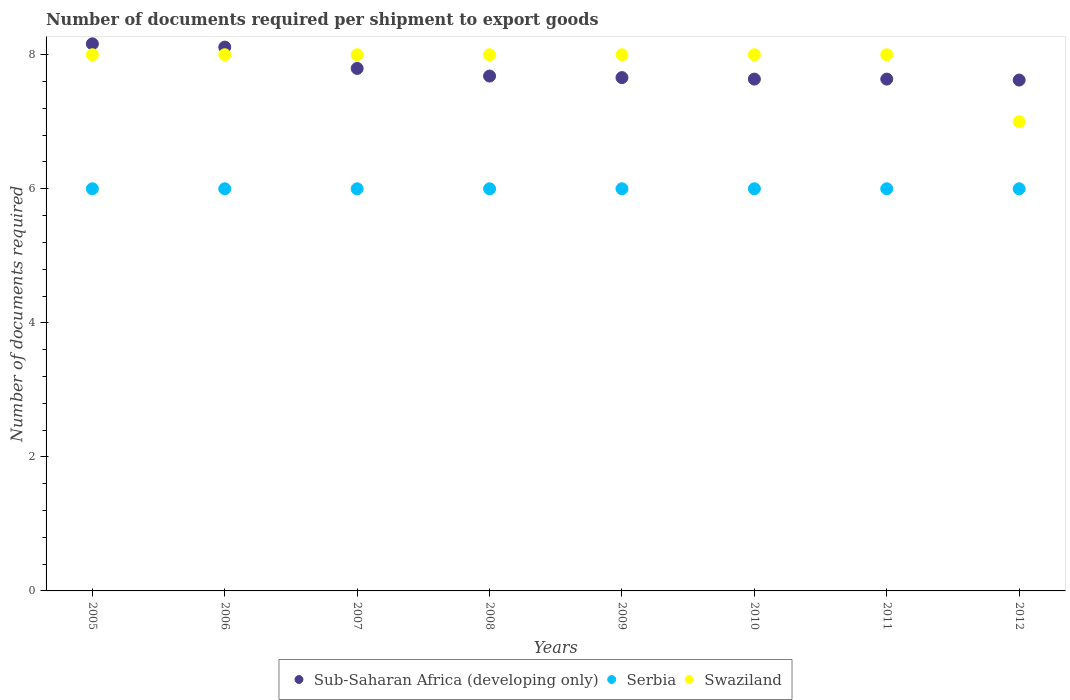How many different coloured dotlines are there?
Your answer should be compact. 3. Is the number of dotlines equal to the number of legend labels?
Your answer should be very brief. Yes. What is the number of documents required per shipment to export goods in Serbia in 2005?
Keep it short and to the point. 6. Across all years, what is the maximum number of documents required per shipment to export goods in Sub-Saharan Africa (developing only)?
Make the answer very short. 8.16. Across all years, what is the minimum number of documents required per shipment to export goods in Swaziland?
Provide a succinct answer. 7. What is the total number of documents required per shipment to export goods in Sub-Saharan Africa (developing only) in the graph?
Give a very brief answer. 62.31. What is the difference between the number of documents required per shipment to export goods in Sub-Saharan Africa (developing only) in 2005 and the number of documents required per shipment to export goods in Swaziland in 2008?
Your answer should be compact. 0.16. What is the average number of documents required per shipment to export goods in Serbia per year?
Ensure brevity in your answer.  6. In the year 2011, what is the difference between the number of documents required per shipment to export goods in Swaziland and number of documents required per shipment to export goods in Sub-Saharan Africa (developing only)?
Ensure brevity in your answer.  0.36. In how many years, is the number of documents required per shipment to export goods in Swaziland greater than 6.4?
Keep it short and to the point. 8. What is the ratio of the number of documents required per shipment to export goods in Sub-Saharan Africa (developing only) in 2007 to that in 2009?
Provide a short and direct response. 1.02. Is the number of documents required per shipment to export goods in Sub-Saharan Africa (developing only) in 2007 less than that in 2011?
Offer a very short reply. No. Is the difference between the number of documents required per shipment to export goods in Swaziland in 2009 and 2012 greater than the difference between the number of documents required per shipment to export goods in Sub-Saharan Africa (developing only) in 2009 and 2012?
Ensure brevity in your answer.  Yes. What is the difference between the highest and the second highest number of documents required per shipment to export goods in Serbia?
Your response must be concise. 0. What is the difference between the highest and the lowest number of documents required per shipment to export goods in Swaziland?
Provide a short and direct response. 1. Is it the case that in every year, the sum of the number of documents required per shipment to export goods in Sub-Saharan Africa (developing only) and number of documents required per shipment to export goods in Serbia  is greater than the number of documents required per shipment to export goods in Swaziland?
Your answer should be very brief. Yes. Does the number of documents required per shipment to export goods in Serbia monotonically increase over the years?
Your answer should be very brief. No. Is the number of documents required per shipment to export goods in Swaziland strictly greater than the number of documents required per shipment to export goods in Sub-Saharan Africa (developing only) over the years?
Your response must be concise. No. Is the number of documents required per shipment to export goods in Sub-Saharan Africa (developing only) strictly less than the number of documents required per shipment to export goods in Swaziland over the years?
Your answer should be compact. No. How many years are there in the graph?
Provide a succinct answer. 8. How many legend labels are there?
Ensure brevity in your answer.  3. What is the title of the graph?
Keep it short and to the point. Number of documents required per shipment to export goods. What is the label or title of the X-axis?
Keep it short and to the point. Years. What is the label or title of the Y-axis?
Ensure brevity in your answer.  Number of documents required. What is the Number of documents required in Sub-Saharan Africa (developing only) in 2005?
Offer a very short reply. 8.16. What is the Number of documents required of Swaziland in 2005?
Ensure brevity in your answer.  8. What is the Number of documents required of Sub-Saharan Africa (developing only) in 2006?
Provide a succinct answer. 8.11. What is the Number of documents required of Swaziland in 2006?
Your answer should be compact. 8. What is the Number of documents required of Sub-Saharan Africa (developing only) in 2007?
Offer a very short reply. 7.8. What is the Number of documents required in Swaziland in 2007?
Provide a succinct answer. 8. What is the Number of documents required in Sub-Saharan Africa (developing only) in 2008?
Your answer should be compact. 7.68. What is the Number of documents required of Serbia in 2008?
Make the answer very short. 6. What is the Number of documents required in Swaziland in 2008?
Offer a terse response. 8. What is the Number of documents required of Sub-Saharan Africa (developing only) in 2009?
Give a very brief answer. 7.66. What is the Number of documents required of Swaziland in 2009?
Provide a short and direct response. 8. What is the Number of documents required in Sub-Saharan Africa (developing only) in 2010?
Give a very brief answer. 7.64. What is the Number of documents required of Serbia in 2010?
Give a very brief answer. 6. What is the Number of documents required of Swaziland in 2010?
Offer a terse response. 8. What is the Number of documents required in Sub-Saharan Africa (developing only) in 2011?
Offer a very short reply. 7.64. What is the Number of documents required in Serbia in 2011?
Your answer should be very brief. 6. What is the Number of documents required in Sub-Saharan Africa (developing only) in 2012?
Offer a terse response. 7.62. Across all years, what is the maximum Number of documents required of Sub-Saharan Africa (developing only)?
Your response must be concise. 8.16. Across all years, what is the maximum Number of documents required of Swaziland?
Provide a succinct answer. 8. Across all years, what is the minimum Number of documents required of Sub-Saharan Africa (developing only)?
Make the answer very short. 7.62. What is the total Number of documents required in Sub-Saharan Africa (developing only) in the graph?
Make the answer very short. 62.31. What is the total Number of documents required of Swaziland in the graph?
Ensure brevity in your answer.  63. What is the difference between the Number of documents required of Sub-Saharan Africa (developing only) in 2005 and that in 2006?
Keep it short and to the point. 0.05. What is the difference between the Number of documents required of Sub-Saharan Africa (developing only) in 2005 and that in 2007?
Offer a terse response. 0.37. What is the difference between the Number of documents required of Sub-Saharan Africa (developing only) in 2005 and that in 2008?
Make the answer very short. 0.48. What is the difference between the Number of documents required of Serbia in 2005 and that in 2008?
Make the answer very short. 0. What is the difference between the Number of documents required in Sub-Saharan Africa (developing only) in 2005 and that in 2009?
Offer a terse response. 0.5. What is the difference between the Number of documents required of Serbia in 2005 and that in 2009?
Give a very brief answer. 0. What is the difference between the Number of documents required of Sub-Saharan Africa (developing only) in 2005 and that in 2010?
Make the answer very short. 0.53. What is the difference between the Number of documents required of Swaziland in 2005 and that in 2010?
Ensure brevity in your answer.  0. What is the difference between the Number of documents required in Sub-Saharan Africa (developing only) in 2005 and that in 2011?
Your answer should be compact. 0.53. What is the difference between the Number of documents required of Serbia in 2005 and that in 2011?
Offer a terse response. 0. What is the difference between the Number of documents required of Sub-Saharan Africa (developing only) in 2005 and that in 2012?
Give a very brief answer. 0.54. What is the difference between the Number of documents required of Serbia in 2005 and that in 2012?
Ensure brevity in your answer.  0. What is the difference between the Number of documents required in Swaziland in 2005 and that in 2012?
Keep it short and to the point. 1. What is the difference between the Number of documents required in Sub-Saharan Africa (developing only) in 2006 and that in 2007?
Offer a very short reply. 0.32. What is the difference between the Number of documents required of Serbia in 2006 and that in 2007?
Your answer should be compact. 0. What is the difference between the Number of documents required in Swaziland in 2006 and that in 2007?
Keep it short and to the point. 0. What is the difference between the Number of documents required in Sub-Saharan Africa (developing only) in 2006 and that in 2008?
Give a very brief answer. 0.43. What is the difference between the Number of documents required in Swaziland in 2006 and that in 2008?
Offer a very short reply. 0. What is the difference between the Number of documents required in Sub-Saharan Africa (developing only) in 2006 and that in 2009?
Provide a succinct answer. 0.45. What is the difference between the Number of documents required in Sub-Saharan Africa (developing only) in 2006 and that in 2010?
Ensure brevity in your answer.  0.48. What is the difference between the Number of documents required in Swaziland in 2006 and that in 2010?
Provide a short and direct response. 0. What is the difference between the Number of documents required of Sub-Saharan Africa (developing only) in 2006 and that in 2011?
Your answer should be compact. 0.48. What is the difference between the Number of documents required in Swaziland in 2006 and that in 2011?
Provide a short and direct response. 0. What is the difference between the Number of documents required in Sub-Saharan Africa (developing only) in 2006 and that in 2012?
Provide a succinct answer. 0.49. What is the difference between the Number of documents required in Serbia in 2006 and that in 2012?
Give a very brief answer. 0. What is the difference between the Number of documents required in Sub-Saharan Africa (developing only) in 2007 and that in 2008?
Your answer should be compact. 0.11. What is the difference between the Number of documents required of Serbia in 2007 and that in 2008?
Make the answer very short. 0. What is the difference between the Number of documents required in Sub-Saharan Africa (developing only) in 2007 and that in 2009?
Ensure brevity in your answer.  0.14. What is the difference between the Number of documents required of Sub-Saharan Africa (developing only) in 2007 and that in 2010?
Give a very brief answer. 0.16. What is the difference between the Number of documents required in Swaziland in 2007 and that in 2010?
Make the answer very short. 0. What is the difference between the Number of documents required in Sub-Saharan Africa (developing only) in 2007 and that in 2011?
Give a very brief answer. 0.16. What is the difference between the Number of documents required in Swaziland in 2007 and that in 2011?
Give a very brief answer. 0. What is the difference between the Number of documents required of Sub-Saharan Africa (developing only) in 2007 and that in 2012?
Provide a succinct answer. 0.17. What is the difference between the Number of documents required in Serbia in 2007 and that in 2012?
Offer a very short reply. 0. What is the difference between the Number of documents required in Sub-Saharan Africa (developing only) in 2008 and that in 2009?
Give a very brief answer. 0.02. What is the difference between the Number of documents required of Serbia in 2008 and that in 2009?
Ensure brevity in your answer.  0. What is the difference between the Number of documents required of Swaziland in 2008 and that in 2009?
Provide a short and direct response. 0. What is the difference between the Number of documents required in Sub-Saharan Africa (developing only) in 2008 and that in 2010?
Provide a succinct answer. 0.05. What is the difference between the Number of documents required of Sub-Saharan Africa (developing only) in 2008 and that in 2011?
Provide a succinct answer. 0.05. What is the difference between the Number of documents required in Serbia in 2008 and that in 2011?
Provide a succinct answer. 0. What is the difference between the Number of documents required in Swaziland in 2008 and that in 2011?
Your answer should be very brief. 0. What is the difference between the Number of documents required of Sub-Saharan Africa (developing only) in 2008 and that in 2012?
Offer a very short reply. 0.06. What is the difference between the Number of documents required of Sub-Saharan Africa (developing only) in 2009 and that in 2010?
Provide a succinct answer. 0.02. What is the difference between the Number of documents required of Sub-Saharan Africa (developing only) in 2009 and that in 2011?
Ensure brevity in your answer.  0.02. What is the difference between the Number of documents required in Sub-Saharan Africa (developing only) in 2009 and that in 2012?
Ensure brevity in your answer.  0.04. What is the difference between the Number of documents required in Serbia in 2009 and that in 2012?
Provide a succinct answer. 0. What is the difference between the Number of documents required in Swaziland in 2009 and that in 2012?
Your answer should be very brief. 1. What is the difference between the Number of documents required of Sub-Saharan Africa (developing only) in 2010 and that in 2011?
Provide a short and direct response. 0. What is the difference between the Number of documents required in Serbia in 2010 and that in 2011?
Keep it short and to the point. 0. What is the difference between the Number of documents required of Sub-Saharan Africa (developing only) in 2010 and that in 2012?
Offer a terse response. 0.01. What is the difference between the Number of documents required of Swaziland in 2010 and that in 2012?
Offer a very short reply. 1. What is the difference between the Number of documents required in Sub-Saharan Africa (developing only) in 2011 and that in 2012?
Provide a succinct answer. 0.01. What is the difference between the Number of documents required of Serbia in 2011 and that in 2012?
Make the answer very short. 0. What is the difference between the Number of documents required of Swaziland in 2011 and that in 2012?
Your answer should be compact. 1. What is the difference between the Number of documents required of Sub-Saharan Africa (developing only) in 2005 and the Number of documents required of Serbia in 2006?
Provide a succinct answer. 2.16. What is the difference between the Number of documents required in Sub-Saharan Africa (developing only) in 2005 and the Number of documents required in Swaziland in 2006?
Provide a succinct answer. 0.16. What is the difference between the Number of documents required of Sub-Saharan Africa (developing only) in 2005 and the Number of documents required of Serbia in 2007?
Provide a succinct answer. 2.16. What is the difference between the Number of documents required in Sub-Saharan Africa (developing only) in 2005 and the Number of documents required in Swaziland in 2007?
Your response must be concise. 0.16. What is the difference between the Number of documents required of Sub-Saharan Africa (developing only) in 2005 and the Number of documents required of Serbia in 2008?
Provide a short and direct response. 2.16. What is the difference between the Number of documents required of Sub-Saharan Africa (developing only) in 2005 and the Number of documents required of Swaziland in 2008?
Provide a succinct answer. 0.16. What is the difference between the Number of documents required in Serbia in 2005 and the Number of documents required in Swaziland in 2008?
Give a very brief answer. -2. What is the difference between the Number of documents required in Sub-Saharan Africa (developing only) in 2005 and the Number of documents required in Serbia in 2009?
Provide a short and direct response. 2.16. What is the difference between the Number of documents required of Sub-Saharan Africa (developing only) in 2005 and the Number of documents required of Swaziland in 2009?
Provide a succinct answer. 0.16. What is the difference between the Number of documents required of Sub-Saharan Africa (developing only) in 2005 and the Number of documents required of Serbia in 2010?
Your response must be concise. 2.16. What is the difference between the Number of documents required in Sub-Saharan Africa (developing only) in 2005 and the Number of documents required in Swaziland in 2010?
Offer a terse response. 0.16. What is the difference between the Number of documents required of Sub-Saharan Africa (developing only) in 2005 and the Number of documents required of Serbia in 2011?
Give a very brief answer. 2.16. What is the difference between the Number of documents required in Sub-Saharan Africa (developing only) in 2005 and the Number of documents required in Swaziland in 2011?
Keep it short and to the point. 0.16. What is the difference between the Number of documents required of Sub-Saharan Africa (developing only) in 2005 and the Number of documents required of Serbia in 2012?
Give a very brief answer. 2.16. What is the difference between the Number of documents required in Sub-Saharan Africa (developing only) in 2005 and the Number of documents required in Swaziland in 2012?
Ensure brevity in your answer.  1.16. What is the difference between the Number of documents required of Serbia in 2005 and the Number of documents required of Swaziland in 2012?
Your answer should be compact. -1. What is the difference between the Number of documents required in Sub-Saharan Africa (developing only) in 2006 and the Number of documents required in Serbia in 2007?
Your response must be concise. 2.11. What is the difference between the Number of documents required of Sub-Saharan Africa (developing only) in 2006 and the Number of documents required of Swaziland in 2007?
Provide a succinct answer. 0.11. What is the difference between the Number of documents required of Sub-Saharan Africa (developing only) in 2006 and the Number of documents required of Serbia in 2008?
Provide a succinct answer. 2.11. What is the difference between the Number of documents required of Sub-Saharan Africa (developing only) in 2006 and the Number of documents required of Swaziland in 2008?
Your answer should be compact. 0.11. What is the difference between the Number of documents required of Serbia in 2006 and the Number of documents required of Swaziland in 2008?
Keep it short and to the point. -2. What is the difference between the Number of documents required in Sub-Saharan Africa (developing only) in 2006 and the Number of documents required in Serbia in 2009?
Your answer should be compact. 2.11. What is the difference between the Number of documents required of Sub-Saharan Africa (developing only) in 2006 and the Number of documents required of Swaziland in 2009?
Make the answer very short. 0.11. What is the difference between the Number of documents required in Sub-Saharan Africa (developing only) in 2006 and the Number of documents required in Serbia in 2010?
Your answer should be compact. 2.11. What is the difference between the Number of documents required of Sub-Saharan Africa (developing only) in 2006 and the Number of documents required of Swaziland in 2010?
Keep it short and to the point. 0.11. What is the difference between the Number of documents required of Sub-Saharan Africa (developing only) in 2006 and the Number of documents required of Serbia in 2011?
Keep it short and to the point. 2.11. What is the difference between the Number of documents required of Sub-Saharan Africa (developing only) in 2006 and the Number of documents required of Swaziland in 2011?
Offer a very short reply. 0.11. What is the difference between the Number of documents required of Serbia in 2006 and the Number of documents required of Swaziland in 2011?
Your response must be concise. -2. What is the difference between the Number of documents required of Sub-Saharan Africa (developing only) in 2006 and the Number of documents required of Serbia in 2012?
Offer a very short reply. 2.11. What is the difference between the Number of documents required in Sub-Saharan Africa (developing only) in 2006 and the Number of documents required in Swaziland in 2012?
Provide a short and direct response. 1.11. What is the difference between the Number of documents required in Sub-Saharan Africa (developing only) in 2007 and the Number of documents required in Serbia in 2008?
Provide a short and direct response. 1.8. What is the difference between the Number of documents required of Sub-Saharan Africa (developing only) in 2007 and the Number of documents required of Swaziland in 2008?
Offer a terse response. -0.2. What is the difference between the Number of documents required of Serbia in 2007 and the Number of documents required of Swaziland in 2008?
Offer a very short reply. -2. What is the difference between the Number of documents required of Sub-Saharan Africa (developing only) in 2007 and the Number of documents required of Serbia in 2009?
Your answer should be compact. 1.8. What is the difference between the Number of documents required in Sub-Saharan Africa (developing only) in 2007 and the Number of documents required in Swaziland in 2009?
Provide a short and direct response. -0.2. What is the difference between the Number of documents required of Sub-Saharan Africa (developing only) in 2007 and the Number of documents required of Serbia in 2010?
Ensure brevity in your answer.  1.8. What is the difference between the Number of documents required of Sub-Saharan Africa (developing only) in 2007 and the Number of documents required of Swaziland in 2010?
Ensure brevity in your answer.  -0.2. What is the difference between the Number of documents required of Serbia in 2007 and the Number of documents required of Swaziland in 2010?
Give a very brief answer. -2. What is the difference between the Number of documents required of Sub-Saharan Africa (developing only) in 2007 and the Number of documents required of Serbia in 2011?
Keep it short and to the point. 1.8. What is the difference between the Number of documents required of Sub-Saharan Africa (developing only) in 2007 and the Number of documents required of Swaziland in 2011?
Make the answer very short. -0.2. What is the difference between the Number of documents required of Sub-Saharan Africa (developing only) in 2007 and the Number of documents required of Serbia in 2012?
Offer a very short reply. 1.8. What is the difference between the Number of documents required in Sub-Saharan Africa (developing only) in 2007 and the Number of documents required in Swaziland in 2012?
Provide a succinct answer. 0.8. What is the difference between the Number of documents required in Sub-Saharan Africa (developing only) in 2008 and the Number of documents required in Serbia in 2009?
Make the answer very short. 1.68. What is the difference between the Number of documents required of Sub-Saharan Africa (developing only) in 2008 and the Number of documents required of Swaziland in 2009?
Your answer should be very brief. -0.32. What is the difference between the Number of documents required of Serbia in 2008 and the Number of documents required of Swaziland in 2009?
Provide a short and direct response. -2. What is the difference between the Number of documents required in Sub-Saharan Africa (developing only) in 2008 and the Number of documents required in Serbia in 2010?
Keep it short and to the point. 1.68. What is the difference between the Number of documents required of Sub-Saharan Africa (developing only) in 2008 and the Number of documents required of Swaziland in 2010?
Your answer should be very brief. -0.32. What is the difference between the Number of documents required in Serbia in 2008 and the Number of documents required in Swaziland in 2010?
Provide a succinct answer. -2. What is the difference between the Number of documents required of Sub-Saharan Africa (developing only) in 2008 and the Number of documents required of Serbia in 2011?
Provide a short and direct response. 1.68. What is the difference between the Number of documents required of Sub-Saharan Africa (developing only) in 2008 and the Number of documents required of Swaziland in 2011?
Ensure brevity in your answer.  -0.32. What is the difference between the Number of documents required in Serbia in 2008 and the Number of documents required in Swaziland in 2011?
Provide a succinct answer. -2. What is the difference between the Number of documents required in Sub-Saharan Africa (developing only) in 2008 and the Number of documents required in Serbia in 2012?
Give a very brief answer. 1.68. What is the difference between the Number of documents required of Sub-Saharan Africa (developing only) in 2008 and the Number of documents required of Swaziland in 2012?
Provide a short and direct response. 0.68. What is the difference between the Number of documents required in Sub-Saharan Africa (developing only) in 2009 and the Number of documents required in Serbia in 2010?
Keep it short and to the point. 1.66. What is the difference between the Number of documents required of Sub-Saharan Africa (developing only) in 2009 and the Number of documents required of Swaziland in 2010?
Offer a very short reply. -0.34. What is the difference between the Number of documents required of Serbia in 2009 and the Number of documents required of Swaziland in 2010?
Your answer should be very brief. -2. What is the difference between the Number of documents required of Sub-Saharan Africa (developing only) in 2009 and the Number of documents required of Serbia in 2011?
Give a very brief answer. 1.66. What is the difference between the Number of documents required in Sub-Saharan Africa (developing only) in 2009 and the Number of documents required in Swaziland in 2011?
Give a very brief answer. -0.34. What is the difference between the Number of documents required of Sub-Saharan Africa (developing only) in 2009 and the Number of documents required of Serbia in 2012?
Offer a very short reply. 1.66. What is the difference between the Number of documents required of Sub-Saharan Africa (developing only) in 2009 and the Number of documents required of Swaziland in 2012?
Provide a short and direct response. 0.66. What is the difference between the Number of documents required in Serbia in 2009 and the Number of documents required in Swaziland in 2012?
Offer a terse response. -1. What is the difference between the Number of documents required in Sub-Saharan Africa (developing only) in 2010 and the Number of documents required in Serbia in 2011?
Make the answer very short. 1.64. What is the difference between the Number of documents required in Sub-Saharan Africa (developing only) in 2010 and the Number of documents required in Swaziland in 2011?
Ensure brevity in your answer.  -0.36. What is the difference between the Number of documents required in Serbia in 2010 and the Number of documents required in Swaziland in 2011?
Provide a short and direct response. -2. What is the difference between the Number of documents required of Sub-Saharan Africa (developing only) in 2010 and the Number of documents required of Serbia in 2012?
Ensure brevity in your answer.  1.64. What is the difference between the Number of documents required of Sub-Saharan Africa (developing only) in 2010 and the Number of documents required of Swaziland in 2012?
Provide a succinct answer. 0.64. What is the difference between the Number of documents required in Sub-Saharan Africa (developing only) in 2011 and the Number of documents required in Serbia in 2012?
Give a very brief answer. 1.64. What is the difference between the Number of documents required in Sub-Saharan Africa (developing only) in 2011 and the Number of documents required in Swaziland in 2012?
Offer a very short reply. 0.64. What is the average Number of documents required of Sub-Saharan Africa (developing only) per year?
Provide a succinct answer. 7.79. What is the average Number of documents required in Serbia per year?
Your answer should be very brief. 6. What is the average Number of documents required in Swaziland per year?
Make the answer very short. 7.88. In the year 2005, what is the difference between the Number of documents required of Sub-Saharan Africa (developing only) and Number of documents required of Serbia?
Keep it short and to the point. 2.16. In the year 2005, what is the difference between the Number of documents required of Sub-Saharan Africa (developing only) and Number of documents required of Swaziland?
Provide a short and direct response. 0.16. In the year 2005, what is the difference between the Number of documents required of Serbia and Number of documents required of Swaziland?
Provide a short and direct response. -2. In the year 2006, what is the difference between the Number of documents required in Sub-Saharan Africa (developing only) and Number of documents required in Serbia?
Your answer should be very brief. 2.11. In the year 2006, what is the difference between the Number of documents required in Sub-Saharan Africa (developing only) and Number of documents required in Swaziland?
Make the answer very short. 0.11. In the year 2007, what is the difference between the Number of documents required of Sub-Saharan Africa (developing only) and Number of documents required of Serbia?
Make the answer very short. 1.8. In the year 2007, what is the difference between the Number of documents required in Sub-Saharan Africa (developing only) and Number of documents required in Swaziland?
Keep it short and to the point. -0.2. In the year 2008, what is the difference between the Number of documents required in Sub-Saharan Africa (developing only) and Number of documents required in Serbia?
Offer a very short reply. 1.68. In the year 2008, what is the difference between the Number of documents required in Sub-Saharan Africa (developing only) and Number of documents required in Swaziland?
Your answer should be very brief. -0.32. In the year 2009, what is the difference between the Number of documents required of Sub-Saharan Africa (developing only) and Number of documents required of Serbia?
Offer a very short reply. 1.66. In the year 2009, what is the difference between the Number of documents required of Sub-Saharan Africa (developing only) and Number of documents required of Swaziland?
Make the answer very short. -0.34. In the year 2009, what is the difference between the Number of documents required in Serbia and Number of documents required in Swaziland?
Offer a very short reply. -2. In the year 2010, what is the difference between the Number of documents required in Sub-Saharan Africa (developing only) and Number of documents required in Serbia?
Offer a terse response. 1.64. In the year 2010, what is the difference between the Number of documents required of Sub-Saharan Africa (developing only) and Number of documents required of Swaziland?
Ensure brevity in your answer.  -0.36. In the year 2010, what is the difference between the Number of documents required in Serbia and Number of documents required in Swaziland?
Give a very brief answer. -2. In the year 2011, what is the difference between the Number of documents required in Sub-Saharan Africa (developing only) and Number of documents required in Serbia?
Your answer should be very brief. 1.64. In the year 2011, what is the difference between the Number of documents required in Sub-Saharan Africa (developing only) and Number of documents required in Swaziland?
Keep it short and to the point. -0.36. In the year 2011, what is the difference between the Number of documents required in Serbia and Number of documents required in Swaziland?
Provide a short and direct response. -2. In the year 2012, what is the difference between the Number of documents required in Sub-Saharan Africa (developing only) and Number of documents required in Serbia?
Make the answer very short. 1.62. In the year 2012, what is the difference between the Number of documents required of Sub-Saharan Africa (developing only) and Number of documents required of Swaziland?
Your answer should be compact. 0.62. What is the ratio of the Number of documents required in Swaziland in 2005 to that in 2006?
Ensure brevity in your answer.  1. What is the ratio of the Number of documents required in Sub-Saharan Africa (developing only) in 2005 to that in 2007?
Your response must be concise. 1.05. What is the ratio of the Number of documents required in Swaziland in 2005 to that in 2007?
Offer a terse response. 1. What is the ratio of the Number of documents required of Sub-Saharan Africa (developing only) in 2005 to that in 2008?
Ensure brevity in your answer.  1.06. What is the ratio of the Number of documents required in Swaziland in 2005 to that in 2008?
Your response must be concise. 1. What is the ratio of the Number of documents required of Sub-Saharan Africa (developing only) in 2005 to that in 2009?
Give a very brief answer. 1.07. What is the ratio of the Number of documents required of Serbia in 2005 to that in 2009?
Provide a succinct answer. 1. What is the ratio of the Number of documents required of Swaziland in 2005 to that in 2009?
Provide a succinct answer. 1. What is the ratio of the Number of documents required of Sub-Saharan Africa (developing only) in 2005 to that in 2010?
Offer a very short reply. 1.07. What is the ratio of the Number of documents required of Sub-Saharan Africa (developing only) in 2005 to that in 2011?
Your answer should be compact. 1.07. What is the ratio of the Number of documents required in Serbia in 2005 to that in 2011?
Your answer should be compact. 1. What is the ratio of the Number of documents required of Swaziland in 2005 to that in 2011?
Your answer should be compact. 1. What is the ratio of the Number of documents required in Sub-Saharan Africa (developing only) in 2005 to that in 2012?
Ensure brevity in your answer.  1.07. What is the ratio of the Number of documents required of Sub-Saharan Africa (developing only) in 2006 to that in 2007?
Your response must be concise. 1.04. What is the ratio of the Number of documents required of Sub-Saharan Africa (developing only) in 2006 to that in 2008?
Make the answer very short. 1.06. What is the ratio of the Number of documents required in Swaziland in 2006 to that in 2008?
Your answer should be very brief. 1. What is the ratio of the Number of documents required in Sub-Saharan Africa (developing only) in 2006 to that in 2009?
Provide a succinct answer. 1.06. What is the ratio of the Number of documents required in Swaziland in 2006 to that in 2009?
Your answer should be compact. 1. What is the ratio of the Number of documents required of Sub-Saharan Africa (developing only) in 2006 to that in 2011?
Ensure brevity in your answer.  1.06. What is the ratio of the Number of documents required in Serbia in 2006 to that in 2011?
Make the answer very short. 1. What is the ratio of the Number of documents required in Sub-Saharan Africa (developing only) in 2006 to that in 2012?
Your answer should be very brief. 1.06. What is the ratio of the Number of documents required of Serbia in 2006 to that in 2012?
Offer a very short reply. 1. What is the ratio of the Number of documents required of Swaziland in 2006 to that in 2012?
Offer a very short reply. 1.14. What is the ratio of the Number of documents required of Sub-Saharan Africa (developing only) in 2007 to that in 2008?
Give a very brief answer. 1.01. What is the ratio of the Number of documents required of Swaziland in 2007 to that in 2008?
Your answer should be very brief. 1. What is the ratio of the Number of documents required of Sub-Saharan Africa (developing only) in 2007 to that in 2009?
Offer a very short reply. 1.02. What is the ratio of the Number of documents required of Serbia in 2007 to that in 2009?
Provide a succinct answer. 1. What is the ratio of the Number of documents required in Sub-Saharan Africa (developing only) in 2007 to that in 2010?
Your answer should be compact. 1.02. What is the ratio of the Number of documents required of Serbia in 2007 to that in 2010?
Provide a short and direct response. 1. What is the ratio of the Number of documents required in Swaziland in 2007 to that in 2010?
Give a very brief answer. 1. What is the ratio of the Number of documents required in Sub-Saharan Africa (developing only) in 2007 to that in 2011?
Provide a short and direct response. 1.02. What is the ratio of the Number of documents required of Serbia in 2007 to that in 2011?
Ensure brevity in your answer.  1. What is the ratio of the Number of documents required of Sub-Saharan Africa (developing only) in 2007 to that in 2012?
Your answer should be very brief. 1.02. What is the ratio of the Number of documents required in Sub-Saharan Africa (developing only) in 2008 to that in 2010?
Provide a short and direct response. 1.01. What is the ratio of the Number of documents required in Swaziland in 2008 to that in 2012?
Provide a succinct answer. 1.14. What is the ratio of the Number of documents required of Sub-Saharan Africa (developing only) in 2009 to that in 2010?
Provide a succinct answer. 1. What is the ratio of the Number of documents required in Serbia in 2009 to that in 2010?
Your answer should be very brief. 1. What is the ratio of the Number of documents required in Serbia in 2009 to that in 2012?
Provide a succinct answer. 1. What is the ratio of the Number of documents required of Swaziland in 2009 to that in 2012?
Your response must be concise. 1.14. What is the ratio of the Number of documents required in Sub-Saharan Africa (developing only) in 2010 to that in 2011?
Provide a short and direct response. 1. What is the ratio of the Number of documents required in Swaziland in 2011 to that in 2012?
Give a very brief answer. 1.14. What is the difference between the highest and the second highest Number of documents required in Sub-Saharan Africa (developing only)?
Your answer should be compact. 0.05. What is the difference between the highest and the second highest Number of documents required of Serbia?
Keep it short and to the point. 0. What is the difference between the highest and the second highest Number of documents required in Swaziland?
Your answer should be very brief. 0. What is the difference between the highest and the lowest Number of documents required in Sub-Saharan Africa (developing only)?
Make the answer very short. 0.54. What is the difference between the highest and the lowest Number of documents required in Serbia?
Keep it short and to the point. 0. 